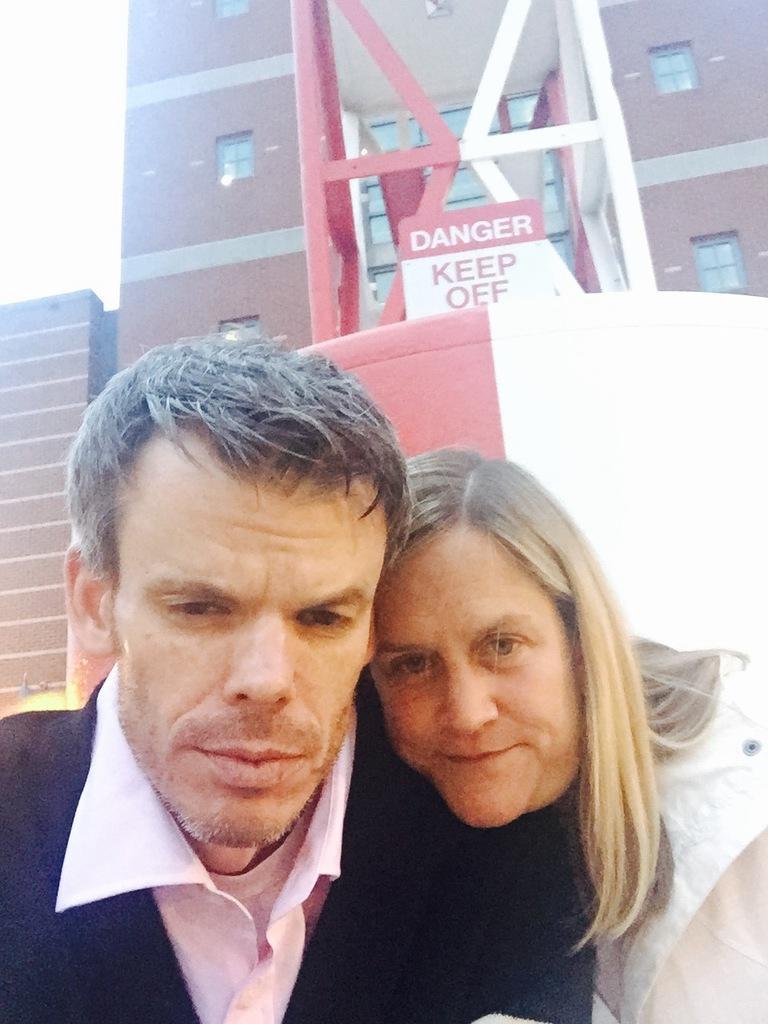How would you summarize this image in a sentence or two? In this picture we can see a man and a woman here, in the background there is a building, we can see a board here. 